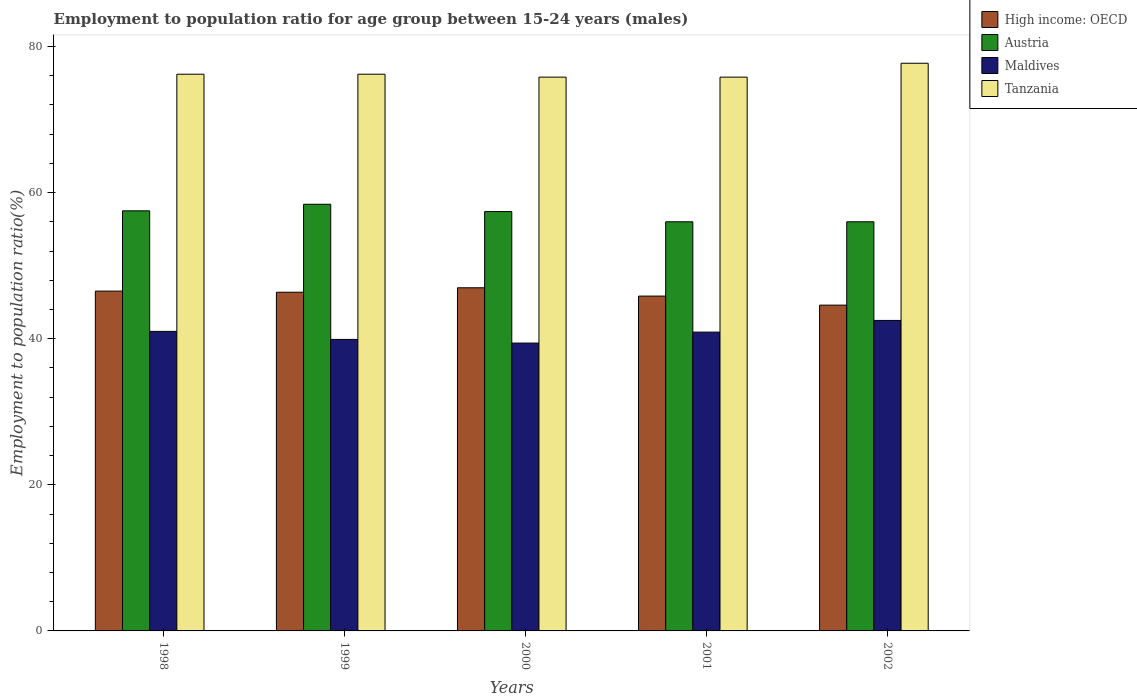How many different coloured bars are there?
Your response must be concise. 4. How many groups of bars are there?
Offer a very short reply. 5. Are the number of bars per tick equal to the number of legend labels?
Keep it short and to the point. Yes. How many bars are there on the 1st tick from the right?
Provide a short and direct response. 4. In how many cases, is the number of bars for a given year not equal to the number of legend labels?
Make the answer very short. 0. What is the employment to population ratio in Maldives in 1999?
Give a very brief answer. 39.9. Across all years, what is the maximum employment to population ratio in Maldives?
Offer a terse response. 42.5. Across all years, what is the minimum employment to population ratio in Tanzania?
Give a very brief answer. 75.8. In which year was the employment to population ratio in Tanzania maximum?
Your answer should be compact. 2002. In which year was the employment to population ratio in High income: OECD minimum?
Offer a terse response. 2002. What is the total employment to population ratio in Maldives in the graph?
Give a very brief answer. 203.7. What is the difference between the employment to population ratio in High income: OECD in 1999 and that in 2000?
Make the answer very short. -0.61. What is the difference between the employment to population ratio in Austria in 2000 and the employment to population ratio in High income: OECD in 1998?
Make the answer very short. 10.89. What is the average employment to population ratio in Tanzania per year?
Offer a terse response. 76.34. In the year 1998, what is the difference between the employment to population ratio in Tanzania and employment to population ratio in Austria?
Provide a short and direct response. 18.7. In how many years, is the employment to population ratio in High income: OECD greater than 44 %?
Your response must be concise. 5. What is the ratio of the employment to population ratio in Maldives in 1999 to that in 2001?
Your answer should be compact. 0.98. Is the employment to population ratio in High income: OECD in 2000 less than that in 2002?
Your answer should be very brief. No. Is the difference between the employment to population ratio in Tanzania in 1999 and 2002 greater than the difference between the employment to population ratio in Austria in 1999 and 2002?
Offer a very short reply. No. What is the difference between the highest and the second highest employment to population ratio in Maldives?
Your answer should be compact. 1.5. What is the difference between the highest and the lowest employment to population ratio in High income: OECD?
Offer a terse response. 2.38. In how many years, is the employment to population ratio in Tanzania greater than the average employment to population ratio in Tanzania taken over all years?
Your response must be concise. 1. Is it the case that in every year, the sum of the employment to population ratio in Austria and employment to population ratio in Maldives is greater than the sum of employment to population ratio in Tanzania and employment to population ratio in High income: OECD?
Your response must be concise. No. What does the 2nd bar from the left in 2002 represents?
Your answer should be very brief. Austria. What does the 4th bar from the right in 1999 represents?
Keep it short and to the point. High income: OECD. How many years are there in the graph?
Your response must be concise. 5. What is the difference between two consecutive major ticks on the Y-axis?
Make the answer very short. 20. Are the values on the major ticks of Y-axis written in scientific E-notation?
Give a very brief answer. No. How many legend labels are there?
Ensure brevity in your answer.  4. What is the title of the graph?
Your answer should be compact. Employment to population ratio for age group between 15-24 years (males). Does "New Caledonia" appear as one of the legend labels in the graph?
Keep it short and to the point. No. What is the label or title of the X-axis?
Offer a very short reply. Years. What is the label or title of the Y-axis?
Make the answer very short. Employment to population ratio(%). What is the Employment to population ratio(%) in High income: OECD in 1998?
Make the answer very short. 46.51. What is the Employment to population ratio(%) in Austria in 1998?
Your answer should be compact. 57.5. What is the Employment to population ratio(%) of Tanzania in 1998?
Offer a terse response. 76.2. What is the Employment to population ratio(%) in High income: OECD in 1999?
Offer a terse response. 46.36. What is the Employment to population ratio(%) of Austria in 1999?
Your answer should be compact. 58.4. What is the Employment to population ratio(%) in Maldives in 1999?
Make the answer very short. 39.9. What is the Employment to population ratio(%) of Tanzania in 1999?
Ensure brevity in your answer.  76.2. What is the Employment to population ratio(%) of High income: OECD in 2000?
Give a very brief answer. 46.97. What is the Employment to population ratio(%) of Austria in 2000?
Give a very brief answer. 57.4. What is the Employment to population ratio(%) of Maldives in 2000?
Ensure brevity in your answer.  39.4. What is the Employment to population ratio(%) in Tanzania in 2000?
Provide a short and direct response. 75.8. What is the Employment to population ratio(%) of High income: OECD in 2001?
Provide a succinct answer. 45.83. What is the Employment to population ratio(%) of Austria in 2001?
Ensure brevity in your answer.  56. What is the Employment to population ratio(%) in Maldives in 2001?
Offer a very short reply. 40.9. What is the Employment to population ratio(%) of Tanzania in 2001?
Make the answer very short. 75.8. What is the Employment to population ratio(%) of High income: OECD in 2002?
Provide a short and direct response. 44.59. What is the Employment to population ratio(%) in Maldives in 2002?
Your response must be concise. 42.5. What is the Employment to population ratio(%) of Tanzania in 2002?
Give a very brief answer. 77.7. Across all years, what is the maximum Employment to population ratio(%) in High income: OECD?
Offer a very short reply. 46.97. Across all years, what is the maximum Employment to population ratio(%) in Austria?
Make the answer very short. 58.4. Across all years, what is the maximum Employment to population ratio(%) in Maldives?
Ensure brevity in your answer.  42.5. Across all years, what is the maximum Employment to population ratio(%) in Tanzania?
Make the answer very short. 77.7. Across all years, what is the minimum Employment to population ratio(%) of High income: OECD?
Provide a short and direct response. 44.59. Across all years, what is the minimum Employment to population ratio(%) of Maldives?
Offer a terse response. 39.4. Across all years, what is the minimum Employment to population ratio(%) of Tanzania?
Your answer should be very brief. 75.8. What is the total Employment to population ratio(%) of High income: OECD in the graph?
Make the answer very short. 230.26. What is the total Employment to population ratio(%) of Austria in the graph?
Make the answer very short. 285.3. What is the total Employment to population ratio(%) of Maldives in the graph?
Provide a succinct answer. 203.7. What is the total Employment to population ratio(%) in Tanzania in the graph?
Provide a short and direct response. 381.7. What is the difference between the Employment to population ratio(%) in High income: OECD in 1998 and that in 1999?
Your answer should be compact. 0.15. What is the difference between the Employment to population ratio(%) of Maldives in 1998 and that in 1999?
Make the answer very short. 1.1. What is the difference between the Employment to population ratio(%) of Tanzania in 1998 and that in 1999?
Make the answer very short. 0. What is the difference between the Employment to population ratio(%) in High income: OECD in 1998 and that in 2000?
Ensure brevity in your answer.  -0.46. What is the difference between the Employment to population ratio(%) of Austria in 1998 and that in 2000?
Your answer should be compact. 0.1. What is the difference between the Employment to population ratio(%) in High income: OECD in 1998 and that in 2001?
Give a very brief answer. 0.68. What is the difference between the Employment to population ratio(%) in Austria in 1998 and that in 2001?
Provide a short and direct response. 1.5. What is the difference between the Employment to population ratio(%) in Tanzania in 1998 and that in 2001?
Offer a very short reply. 0.4. What is the difference between the Employment to population ratio(%) in High income: OECD in 1998 and that in 2002?
Ensure brevity in your answer.  1.92. What is the difference between the Employment to population ratio(%) of Maldives in 1998 and that in 2002?
Offer a terse response. -1.5. What is the difference between the Employment to population ratio(%) of Tanzania in 1998 and that in 2002?
Keep it short and to the point. -1.5. What is the difference between the Employment to population ratio(%) in High income: OECD in 1999 and that in 2000?
Give a very brief answer. -0.61. What is the difference between the Employment to population ratio(%) in Austria in 1999 and that in 2000?
Your answer should be compact. 1. What is the difference between the Employment to population ratio(%) in Maldives in 1999 and that in 2000?
Your answer should be very brief. 0.5. What is the difference between the Employment to population ratio(%) of Tanzania in 1999 and that in 2000?
Keep it short and to the point. 0.4. What is the difference between the Employment to population ratio(%) in High income: OECD in 1999 and that in 2001?
Provide a succinct answer. 0.53. What is the difference between the Employment to population ratio(%) of High income: OECD in 1999 and that in 2002?
Give a very brief answer. 1.77. What is the difference between the Employment to population ratio(%) in Austria in 1999 and that in 2002?
Give a very brief answer. 2.4. What is the difference between the Employment to population ratio(%) in Maldives in 1999 and that in 2002?
Make the answer very short. -2.6. What is the difference between the Employment to population ratio(%) of High income: OECD in 2000 and that in 2001?
Offer a terse response. 1.14. What is the difference between the Employment to population ratio(%) of High income: OECD in 2000 and that in 2002?
Your answer should be very brief. 2.38. What is the difference between the Employment to population ratio(%) in Austria in 2000 and that in 2002?
Your response must be concise. 1.4. What is the difference between the Employment to population ratio(%) of Maldives in 2000 and that in 2002?
Ensure brevity in your answer.  -3.1. What is the difference between the Employment to population ratio(%) of High income: OECD in 2001 and that in 2002?
Keep it short and to the point. 1.24. What is the difference between the Employment to population ratio(%) of Austria in 2001 and that in 2002?
Provide a succinct answer. 0. What is the difference between the Employment to population ratio(%) of Tanzania in 2001 and that in 2002?
Provide a short and direct response. -1.9. What is the difference between the Employment to population ratio(%) in High income: OECD in 1998 and the Employment to population ratio(%) in Austria in 1999?
Give a very brief answer. -11.89. What is the difference between the Employment to population ratio(%) of High income: OECD in 1998 and the Employment to population ratio(%) of Maldives in 1999?
Your response must be concise. 6.61. What is the difference between the Employment to population ratio(%) in High income: OECD in 1998 and the Employment to population ratio(%) in Tanzania in 1999?
Your answer should be very brief. -29.69. What is the difference between the Employment to population ratio(%) in Austria in 1998 and the Employment to population ratio(%) in Tanzania in 1999?
Make the answer very short. -18.7. What is the difference between the Employment to population ratio(%) in Maldives in 1998 and the Employment to population ratio(%) in Tanzania in 1999?
Give a very brief answer. -35.2. What is the difference between the Employment to population ratio(%) in High income: OECD in 1998 and the Employment to population ratio(%) in Austria in 2000?
Provide a short and direct response. -10.89. What is the difference between the Employment to population ratio(%) in High income: OECD in 1998 and the Employment to population ratio(%) in Maldives in 2000?
Your answer should be very brief. 7.11. What is the difference between the Employment to population ratio(%) of High income: OECD in 1998 and the Employment to population ratio(%) of Tanzania in 2000?
Give a very brief answer. -29.29. What is the difference between the Employment to population ratio(%) in Austria in 1998 and the Employment to population ratio(%) in Tanzania in 2000?
Ensure brevity in your answer.  -18.3. What is the difference between the Employment to population ratio(%) in Maldives in 1998 and the Employment to population ratio(%) in Tanzania in 2000?
Your response must be concise. -34.8. What is the difference between the Employment to population ratio(%) of High income: OECD in 1998 and the Employment to population ratio(%) of Austria in 2001?
Offer a very short reply. -9.49. What is the difference between the Employment to population ratio(%) of High income: OECD in 1998 and the Employment to population ratio(%) of Maldives in 2001?
Provide a short and direct response. 5.61. What is the difference between the Employment to population ratio(%) of High income: OECD in 1998 and the Employment to population ratio(%) of Tanzania in 2001?
Ensure brevity in your answer.  -29.29. What is the difference between the Employment to population ratio(%) in Austria in 1998 and the Employment to population ratio(%) in Tanzania in 2001?
Offer a very short reply. -18.3. What is the difference between the Employment to population ratio(%) of Maldives in 1998 and the Employment to population ratio(%) of Tanzania in 2001?
Give a very brief answer. -34.8. What is the difference between the Employment to population ratio(%) of High income: OECD in 1998 and the Employment to population ratio(%) of Austria in 2002?
Make the answer very short. -9.49. What is the difference between the Employment to population ratio(%) in High income: OECD in 1998 and the Employment to population ratio(%) in Maldives in 2002?
Keep it short and to the point. 4.01. What is the difference between the Employment to population ratio(%) in High income: OECD in 1998 and the Employment to population ratio(%) in Tanzania in 2002?
Your response must be concise. -31.19. What is the difference between the Employment to population ratio(%) in Austria in 1998 and the Employment to population ratio(%) in Tanzania in 2002?
Keep it short and to the point. -20.2. What is the difference between the Employment to population ratio(%) of Maldives in 1998 and the Employment to population ratio(%) of Tanzania in 2002?
Keep it short and to the point. -36.7. What is the difference between the Employment to population ratio(%) in High income: OECD in 1999 and the Employment to population ratio(%) in Austria in 2000?
Give a very brief answer. -11.04. What is the difference between the Employment to population ratio(%) in High income: OECD in 1999 and the Employment to population ratio(%) in Maldives in 2000?
Offer a very short reply. 6.96. What is the difference between the Employment to population ratio(%) in High income: OECD in 1999 and the Employment to population ratio(%) in Tanzania in 2000?
Give a very brief answer. -29.44. What is the difference between the Employment to population ratio(%) in Austria in 1999 and the Employment to population ratio(%) in Maldives in 2000?
Your answer should be compact. 19. What is the difference between the Employment to population ratio(%) in Austria in 1999 and the Employment to population ratio(%) in Tanzania in 2000?
Provide a short and direct response. -17.4. What is the difference between the Employment to population ratio(%) in Maldives in 1999 and the Employment to population ratio(%) in Tanzania in 2000?
Keep it short and to the point. -35.9. What is the difference between the Employment to population ratio(%) of High income: OECD in 1999 and the Employment to population ratio(%) of Austria in 2001?
Your response must be concise. -9.64. What is the difference between the Employment to population ratio(%) in High income: OECD in 1999 and the Employment to population ratio(%) in Maldives in 2001?
Your answer should be compact. 5.46. What is the difference between the Employment to population ratio(%) in High income: OECD in 1999 and the Employment to population ratio(%) in Tanzania in 2001?
Your response must be concise. -29.44. What is the difference between the Employment to population ratio(%) of Austria in 1999 and the Employment to population ratio(%) of Maldives in 2001?
Offer a terse response. 17.5. What is the difference between the Employment to population ratio(%) in Austria in 1999 and the Employment to population ratio(%) in Tanzania in 2001?
Your response must be concise. -17.4. What is the difference between the Employment to population ratio(%) of Maldives in 1999 and the Employment to population ratio(%) of Tanzania in 2001?
Your answer should be very brief. -35.9. What is the difference between the Employment to population ratio(%) in High income: OECD in 1999 and the Employment to population ratio(%) in Austria in 2002?
Your response must be concise. -9.64. What is the difference between the Employment to population ratio(%) in High income: OECD in 1999 and the Employment to population ratio(%) in Maldives in 2002?
Ensure brevity in your answer.  3.86. What is the difference between the Employment to population ratio(%) in High income: OECD in 1999 and the Employment to population ratio(%) in Tanzania in 2002?
Your response must be concise. -31.34. What is the difference between the Employment to population ratio(%) of Austria in 1999 and the Employment to population ratio(%) of Maldives in 2002?
Provide a succinct answer. 15.9. What is the difference between the Employment to population ratio(%) in Austria in 1999 and the Employment to population ratio(%) in Tanzania in 2002?
Keep it short and to the point. -19.3. What is the difference between the Employment to population ratio(%) of Maldives in 1999 and the Employment to population ratio(%) of Tanzania in 2002?
Keep it short and to the point. -37.8. What is the difference between the Employment to population ratio(%) of High income: OECD in 2000 and the Employment to population ratio(%) of Austria in 2001?
Keep it short and to the point. -9.03. What is the difference between the Employment to population ratio(%) of High income: OECD in 2000 and the Employment to population ratio(%) of Maldives in 2001?
Give a very brief answer. 6.07. What is the difference between the Employment to population ratio(%) in High income: OECD in 2000 and the Employment to population ratio(%) in Tanzania in 2001?
Offer a very short reply. -28.83. What is the difference between the Employment to population ratio(%) of Austria in 2000 and the Employment to population ratio(%) of Maldives in 2001?
Offer a terse response. 16.5. What is the difference between the Employment to population ratio(%) in Austria in 2000 and the Employment to population ratio(%) in Tanzania in 2001?
Your response must be concise. -18.4. What is the difference between the Employment to population ratio(%) in Maldives in 2000 and the Employment to population ratio(%) in Tanzania in 2001?
Your response must be concise. -36.4. What is the difference between the Employment to population ratio(%) in High income: OECD in 2000 and the Employment to population ratio(%) in Austria in 2002?
Offer a very short reply. -9.03. What is the difference between the Employment to population ratio(%) of High income: OECD in 2000 and the Employment to population ratio(%) of Maldives in 2002?
Offer a very short reply. 4.47. What is the difference between the Employment to population ratio(%) in High income: OECD in 2000 and the Employment to population ratio(%) in Tanzania in 2002?
Offer a terse response. -30.73. What is the difference between the Employment to population ratio(%) of Austria in 2000 and the Employment to population ratio(%) of Maldives in 2002?
Provide a short and direct response. 14.9. What is the difference between the Employment to population ratio(%) in Austria in 2000 and the Employment to population ratio(%) in Tanzania in 2002?
Your response must be concise. -20.3. What is the difference between the Employment to population ratio(%) in Maldives in 2000 and the Employment to population ratio(%) in Tanzania in 2002?
Keep it short and to the point. -38.3. What is the difference between the Employment to population ratio(%) in High income: OECD in 2001 and the Employment to population ratio(%) in Austria in 2002?
Provide a short and direct response. -10.17. What is the difference between the Employment to population ratio(%) of High income: OECD in 2001 and the Employment to population ratio(%) of Maldives in 2002?
Your answer should be very brief. 3.33. What is the difference between the Employment to population ratio(%) in High income: OECD in 2001 and the Employment to population ratio(%) in Tanzania in 2002?
Provide a succinct answer. -31.87. What is the difference between the Employment to population ratio(%) in Austria in 2001 and the Employment to population ratio(%) in Tanzania in 2002?
Provide a succinct answer. -21.7. What is the difference between the Employment to population ratio(%) in Maldives in 2001 and the Employment to population ratio(%) in Tanzania in 2002?
Ensure brevity in your answer.  -36.8. What is the average Employment to population ratio(%) of High income: OECD per year?
Your response must be concise. 46.05. What is the average Employment to population ratio(%) of Austria per year?
Your response must be concise. 57.06. What is the average Employment to population ratio(%) in Maldives per year?
Provide a succinct answer. 40.74. What is the average Employment to population ratio(%) in Tanzania per year?
Your answer should be very brief. 76.34. In the year 1998, what is the difference between the Employment to population ratio(%) in High income: OECD and Employment to population ratio(%) in Austria?
Give a very brief answer. -10.99. In the year 1998, what is the difference between the Employment to population ratio(%) in High income: OECD and Employment to population ratio(%) in Maldives?
Offer a terse response. 5.51. In the year 1998, what is the difference between the Employment to population ratio(%) in High income: OECD and Employment to population ratio(%) in Tanzania?
Keep it short and to the point. -29.69. In the year 1998, what is the difference between the Employment to population ratio(%) in Austria and Employment to population ratio(%) in Maldives?
Make the answer very short. 16.5. In the year 1998, what is the difference between the Employment to population ratio(%) of Austria and Employment to population ratio(%) of Tanzania?
Your response must be concise. -18.7. In the year 1998, what is the difference between the Employment to population ratio(%) in Maldives and Employment to population ratio(%) in Tanzania?
Offer a very short reply. -35.2. In the year 1999, what is the difference between the Employment to population ratio(%) in High income: OECD and Employment to population ratio(%) in Austria?
Provide a succinct answer. -12.04. In the year 1999, what is the difference between the Employment to population ratio(%) of High income: OECD and Employment to population ratio(%) of Maldives?
Your response must be concise. 6.46. In the year 1999, what is the difference between the Employment to population ratio(%) of High income: OECD and Employment to population ratio(%) of Tanzania?
Keep it short and to the point. -29.84. In the year 1999, what is the difference between the Employment to population ratio(%) of Austria and Employment to population ratio(%) of Tanzania?
Your answer should be compact. -17.8. In the year 1999, what is the difference between the Employment to population ratio(%) of Maldives and Employment to population ratio(%) of Tanzania?
Your answer should be very brief. -36.3. In the year 2000, what is the difference between the Employment to population ratio(%) in High income: OECD and Employment to population ratio(%) in Austria?
Ensure brevity in your answer.  -10.43. In the year 2000, what is the difference between the Employment to population ratio(%) in High income: OECD and Employment to population ratio(%) in Maldives?
Ensure brevity in your answer.  7.57. In the year 2000, what is the difference between the Employment to population ratio(%) in High income: OECD and Employment to population ratio(%) in Tanzania?
Ensure brevity in your answer.  -28.83. In the year 2000, what is the difference between the Employment to population ratio(%) in Austria and Employment to population ratio(%) in Maldives?
Your answer should be compact. 18. In the year 2000, what is the difference between the Employment to population ratio(%) of Austria and Employment to population ratio(%) of Tanzania?
Make the answer very short. -18.4. In the year 2000, what is the difference between the Employment to population ratio(%) of Maldives and Employment to population ratio(%) of Tanzania?
Your response must be concise. -36.4. In the year 2001, what is the difference between the Employment to population ratio(%) of High income: OECD and Employment to population ratio(%) of Austria?
Your answer should be very brief. -10.17. In the year 2001, what is the difference between the Employment to population ratio(%) in High income: OECD and Employment to population ratio(%) in Maldives?
Make the answer very short. 4.93. In the year 2001, what is the difference between the Employment to population ratio(%) of High income: OECD and Employment to population ratio(%) of Tanzania?
Your answer should be compact. -29.97. In the year 2001, what is the difference between the Employment to population ratio(%) in Austria and Employment to population ratio(%) in Maldives?
Your response must be concise. 15.1. In the year 2001, what is the difference between the Employment to population ratio(%) of Austria and Employment to population ratio(%) of Tanzania?
Ensure brevity in your answer.  -19.8. In the year 2001, what is the difference between the Employment to population ratio(%) in Maldives and Employment to population ratio(%) in Tanzania?
Provide a succinct answer. -34.9. In the year 2002, what is the difference between the Employment to population ratio(%) in High income: OECD and Employment to population ratio(%) in Austria?
Ensure brevity in your answer.  -11.41. In the year 2002, what is the difference between the Employment to population ratio(%) in High income: OECD and Employment to population ratio(%) in Maldives?
Give a very brief answer. 2.09. In the year 2002, what is the difference between the Employment to population ratio(%) of High income: OECD and Employment to population ratio(%) of Tanzania?
Ensure brevity in your answer.  -33.11. In the year 2002, what is the difference between the Employment to population ratio(%) in Austria and Employment to population ratio(%) in Tanzania?
Offer a very short reply. -21.7. In the year 2002, what is the difference between the Employment to population ratio(%) in Maldives and Employment to population ratio(%) in Tanzania?
Your answer should be very brief. -35.2. What is the ratio of the Employment to population ratio(%) in Austria in 1998 to that in 1999?
Give a very brief answer. 0.98. What is the ratio of the Employment to population ratio(%) of Maldives in 1998 to that in 1999?
Provide a succinct answer. 1.03. What is the ratio of the Employment to population ratio(%) in High income: OECD in 1998 to that in 2000?
Offer a very short reply. 0.99. What is the ratio of the Employment to population ratio(%) in Austria in 1998 to that in 2000?
Your answer should be compact. 1. What is the ratio of the Employment to population ratio(%) of Maldives in 1998 to that in 2000?
Keep it short and to the point. 1.04. What is the ratio of the Employment to population ratio(%) of High income: OECD in 1998 to that in 2001?
Your answer should be very brief. 1.01. What is the ratio of the Employment to population ratio(%) in Austria in 1998 to that in 2001?
Keep it short and to the point. 1.03. What is the ratio of the Employment to population ratio(%) in High income: OECD in 1998 to that in 2002?
Keep it short and to the point. 1.04. What is the ratio of the Employment to population ratio(%) of Austria in 1998 to that in 2002?
Your answer should be compact. 1.03. What is the ratio of the Employment to population ratio(%) in Maldives in 1998 to that in 2002?
Give a very brief answer. 0.96. What is the ratio of the Employment to population ratio(%) in Tanzania in 1998 to that in 2002?
Ensure brevity in your answer.  0.98. What is the ratio of the Employment to population ratio(%) of Austria in 1999 to that in 2000?
Your answer should be very brief. 1.02. What is the ratio of the Employment to population ratio(%) in Maldives in 1999 to that in 2000?
Ensure brevity in your answer.  1.01. What is the ratio of the Employment to population ratio(%) of High income: OECD in 1999 to that in 2001?
Give a very brief answer. 1.01. What is the ratio of the Employment to population ratio(%) in Austria in 1999 to that in 2001?
Ensure brevity in your answer.  1.04. What is the ratio of the Employment to population ratio(%) of Maldives in 1999 to that in 2001?
Offer a very short reply. 0.98. What is the ratio of the Employment to population ratio(%) in Tanzania in 1999 to that in 2001?
Your response must be concise. 1.01. What is the ratio of the Employment to population ratio(%) of High income: OECD in 1999 to that in 2002?
Provide a succinct answer. 1.04. What is the ratio of the Employment to population ratio(%) of Austria in 1999 to that in 2002?
Your response must be concise. 1.04. What is the ratio of the Employment to population ratio(%) of Maldives in 1999 to that in 2002?
Provide a succinct answer. 0.94. What is the ratio of the Employment to population ratio(%) in Tanzania in 1999 to that in 2002?
Offer a terse response. 0.98. What is the ratio of the Employment to population ratio(%) of High income: OECD in 2000 to that in 2001?
Your response must be concise. 1.02. What is the ratio of the Employment to population ratio(%) in Austria in 2000 to that in 2001?
Provide a succinct answer. 1.02. What is the ratio of the Employment to population ratio(%) in Maldives in 2000 to that in 2001?
Provide a succinct answer. 0.96. What is the ratio of the Employment to population ratio(%) of High income: OECD in 2000 to that in 2002?
Offer a very short reply. 1.05. What is the ratio of the Employment to population ratio(%) of Maldives in 2000 to that in 2002?
Make the answer very short. 0.93. What is the ratio of the Employment to population ratio(%) of Tanzania in 2000 to that in 2002?
Give a very brief answer. 0.98. What is the ratio of the Employment to population ratio(%) of High income: OECD in 2001 to that in 2002?
Offer a terse response. 1.03. What is the ratio of the Employment to population ratio(%) in Maldives in 2001 to that in 2002?
Give a very brief answer. 0.96. What is the ratio of the Employment to population ratio(%) of Tanzania in 2001 to that in 2002?
Offer a very short reply. 0.98. What is the difference between the highest and the second highest Employment to population ratio(%) of High income: OECD?
Keep it short and to the point. 0.46. What is the difference between the highest and the lowest Employment to population ratio(%) of High income: OECD?
Your answer should be compact. 2.38. What is the difference between the highest and the lowest Employment to population ratio(%) of Tanzania?
Your answer should be very brief. 1.9. 